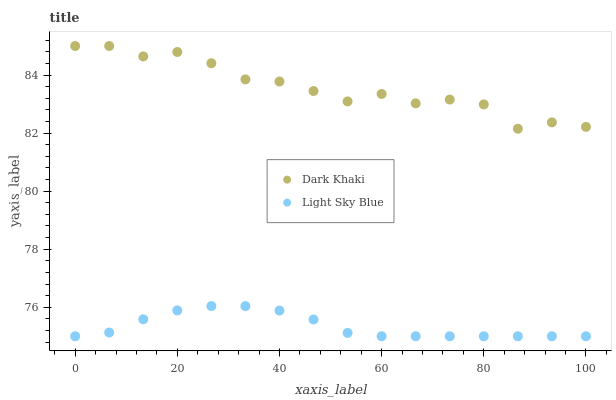Does Light Sky Blue have the minimum area under the curve?
Answer yes or no. Yes. Does Dark Khaki have the maximum area under the curve?
Answer yes or no. Yes. Does Light Sky Blue have the maximum area under the curve?
Answer yes or no. No. Is Light Sky Blue the smoothest?
Answer yes or no. Yes. Is Dark Khaki the roughest?
Answer yes or no. Yes. Is Light Sky Blue the roughest?
Answer yes or no. No. Does Light Sky Blue have the lowest value?
Answer yes or no. Yes. Does Dark Khaki have the highest value?
Answer yes or no. Yes. Does Light Sky Blue have the highest value?
Answer yes or no. No. Is Light Sky Blue less than Dark Khaki?
Answer yes or no. Yes. Is Dark Khaki greater than Light Sky Blue?
Answer yes or no. Yes. Does Light Sky Blue intersect Dark Khaki?
Answer yes or no. No. 